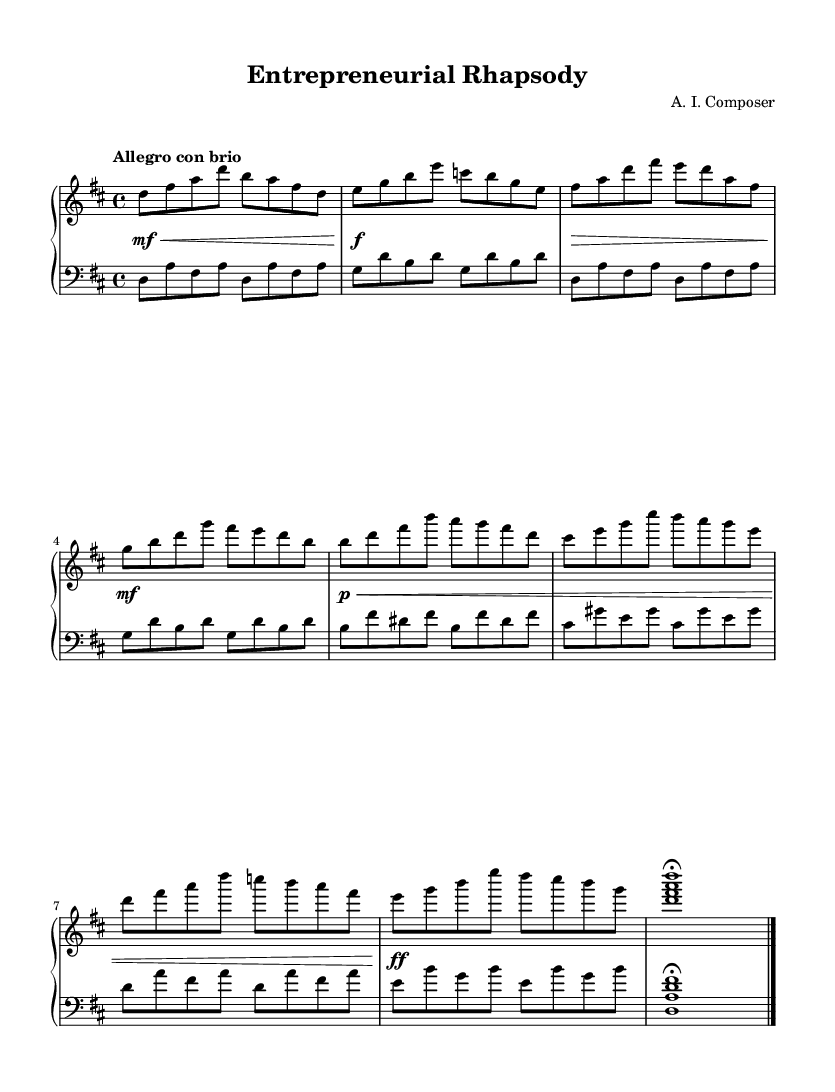What is the key signature of this music? The key signature indicated in the music is D major, which has two sharps (F# and C#). This can be identified from the global section of the score, which states "\key d \major".
Answer: D major What is the time signature of this music? The time signature is 4/4, meaning there are four beats per measure, and each quarter note gets one beat. This is specified in the global section where "\time 4/4" is written.
Answer: 4/4 What is the tempo marking for this piece? The tempo marking is "Allegro con brio", suggesting that the music should be played fast and with vigor. This is indicated in the global section where the tempo is described.
Answer: Allegro con brio How many measures are in the A section? The A section consists of four measures, as indicated by the grouping of notes in the right and left hand within the score. Each new line or phrase typically signifies a complete measure.
Answer: 4 What is the dynamic marking for the ending section? The ending section features a fermata over the chord, indicating that the musician should hold the note longer than its usual duration. This is shown in the dynamics and other markings at the end of the piece.
Answer: Fermata Are there any specific Romantic characteristics displayed in this composition? Yes, the composition includes expressive melodies and dynamic contrasts, typical of the Romantic style, which emphasizes emotion and individuality. This can be observed in the phrases and tempo directions of the piece.
Answer: Expressiveness 